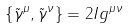Convert formula to latex. <formula><loc_0><loc_0><loc_500><loc_500>\left \{ \tilde { \gamma } ^ { \mu } , \tilde { \gamma } ^ { \nu } \right \} = 2 I g ^ { \mu \nu }</formula> 